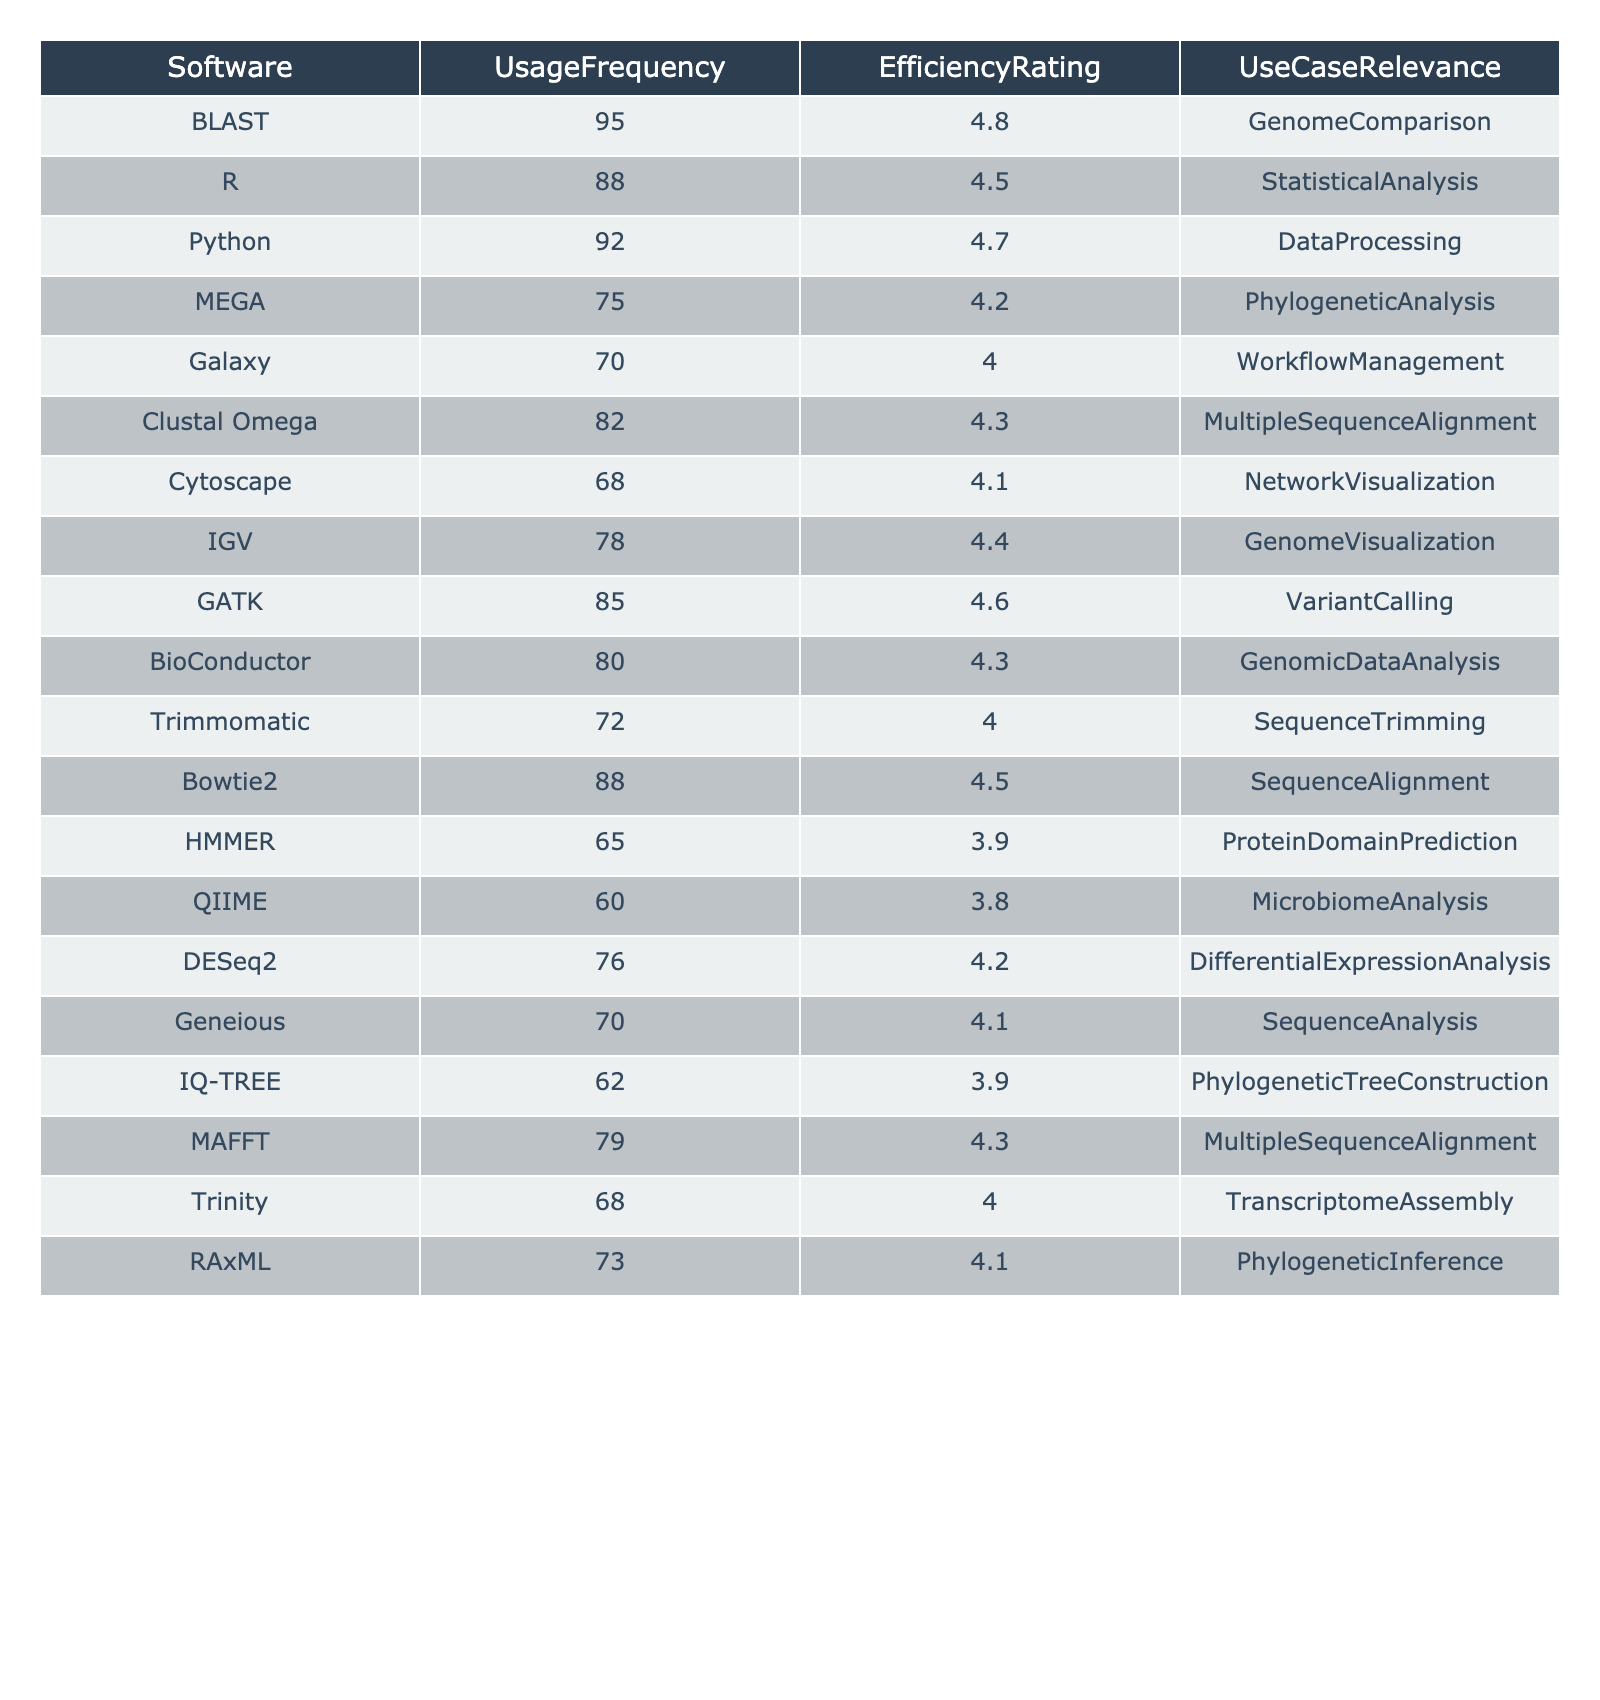What software has the highest usage frequency? By looking at the UsageFrequency column, we see that BLAST has the highest value at 95, which is the peak usage frequency among all the software listed.
Answer: BLAST What is the efficiency rating of QIIME? Referring to the EfficiencyRating column, QIIME has a rating of 3.8 as indicated in the table.
Answer: 3.8 Which software is least relevant for use cases based on the table? To find the least relevant software, QIIME, with a use case relevance of MicrobiomeAnalysis, has a moderate rating in terms of both usage frequency and efficiency. Comparing all entries, it appears to have lesser relevance compared to others, but we could consider the entire dataset for better accuracy. However, exact relevance based on efficiency isn't clearly indicated.
Answer: QIIME What is the average efficiency rating of the software listed that are used for Multiple Sequence Alignment? The relevant software for this use case are Clustal Omega with a rating of 4.3 and MAFFT with a rating of 4.3. Adding these ratings gives 4.3 + 4.3 = 8.6. Dividing by the number of software (2), we get an average efficiency rating of 4.3.
Answer: 4.3 Is the mean usage frequency across all software greater than 80? We first sum the usage frequencies: 95 + 88 + 92 + 75 + 70 + 82 + 68 + 78 + 85 + 80 + 72 + 88 + 65 + 60 + 76 + 70 + 62 + 79 + 68 + 73 = 1363. There are 20 software tools, so we divide by 20. The mean is 1363 / 20 = 68.15, which is not greater than 80.
Answer: No How many software have an efficiency rating of 4.0 or lower? Checking the EfficiencyRating column, we find the software TRIMMOMATIC (4.0), HMMER (3.9), QIIME (3.8), and Galaxy (4.0) have a rating of 4.0 or lower. Counting these entries, we find there are 4 such software.
Answer: 4 Which software has both a high usage frequency (above 90) and a high efficiency rating (above 4.5)? Observing the table, BLAST (95, 4.8), Python (92, 4.7), and GATK (85, 4.6) meet both criteria. Thus, there are three software that fit this description.
Answer: Three What is the combined efficiency rating of tools used for Phylogenetic Analysis? The relevant tools are MEGA (4.2), RAxML (4.1), and IQ-TREE (3.9). Summing these ratings gives 4.2 + 4.1 + 3.9 = 12.2.
Answer: 12.2 Is there any software with a usage frequency below 70? Reviewing the UsageFrequency column, we find that Galaxy (70), Cytoscape (68), HMMER (65), and QIIME (60) have frequencies below 70. Therefore, the answer is yes.
Answer: Yes Which software has the largest gap between usage frequency and efficiency rating? We need to compare each software’s usage frequency and efficiency rating, calculating their difference for each. The largest difference appears to be HMMER, with a value of 65 (usage) and 3.9 (efficiency), giving us a gap of 65 - 3.9 = 61.1, which is the largest in the table.
Answer: HMMER 